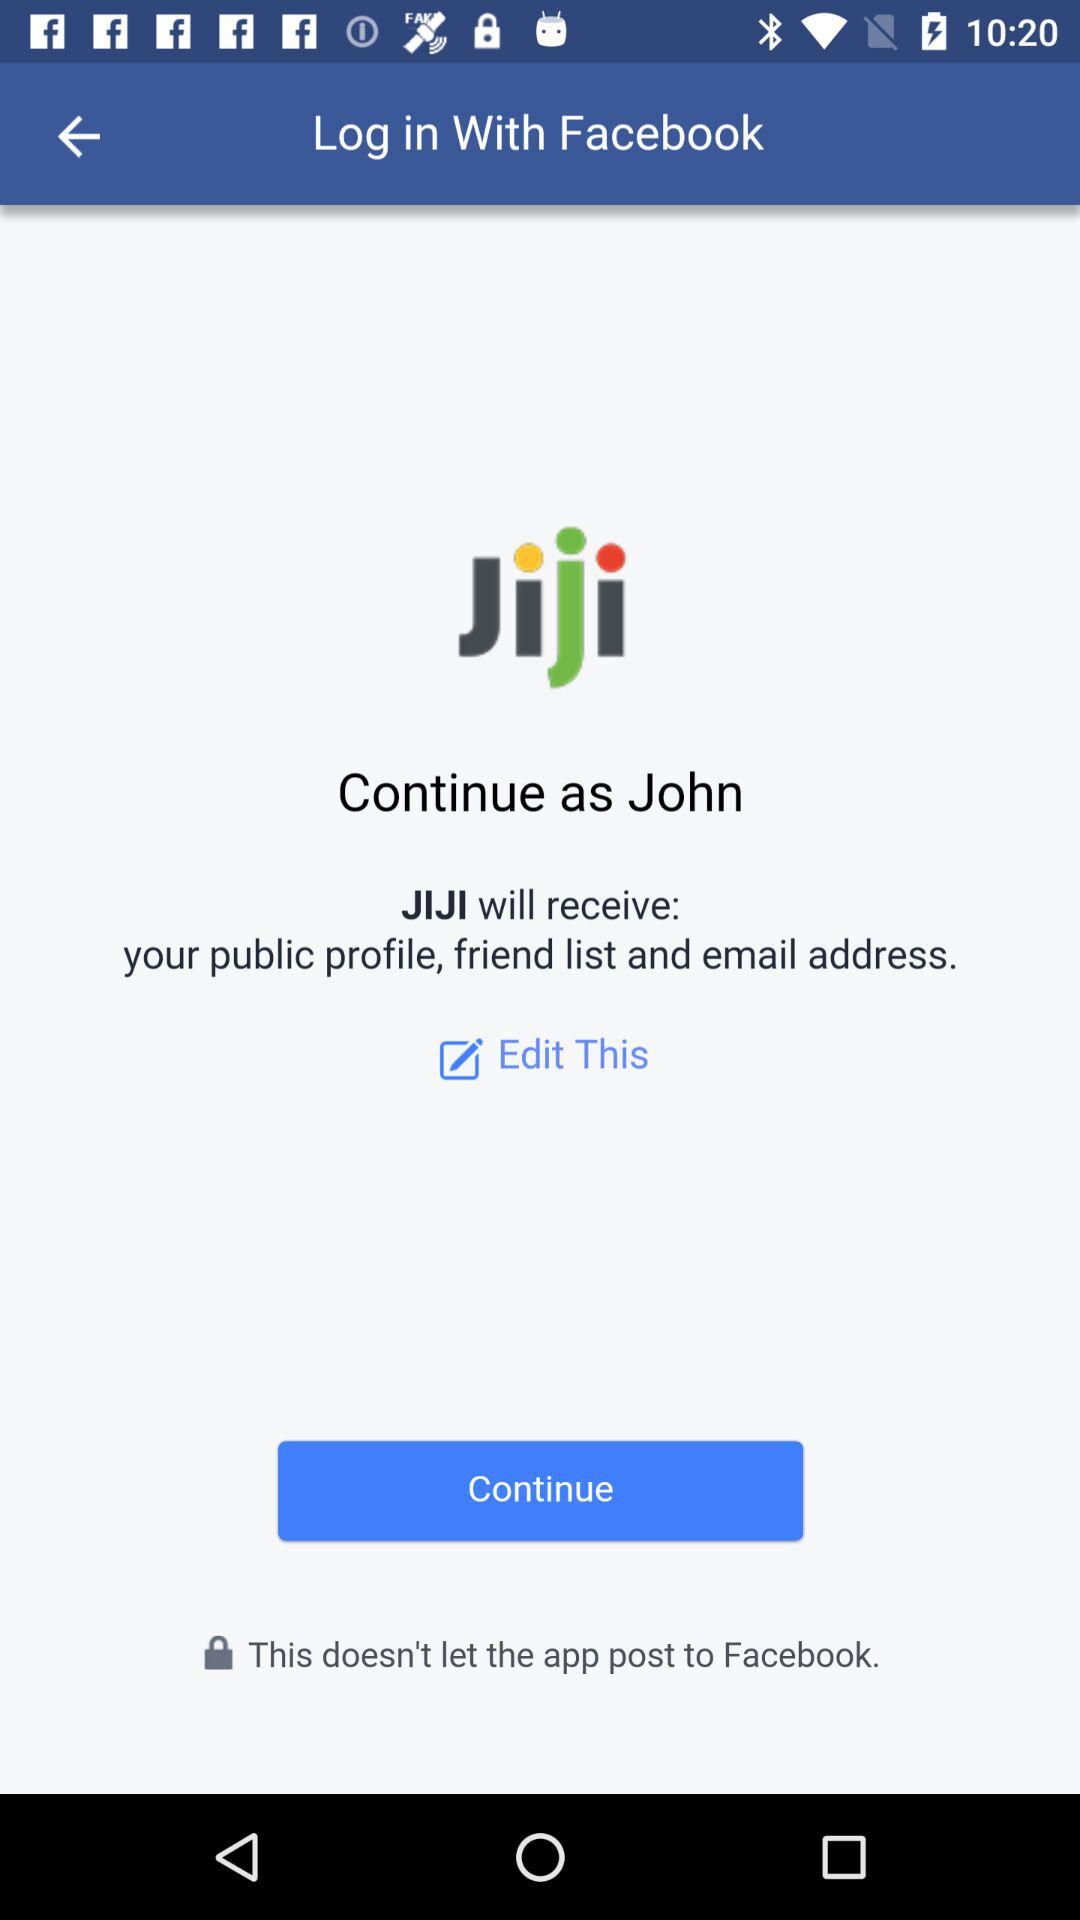What application is used to log in? The application is "Facebook". 